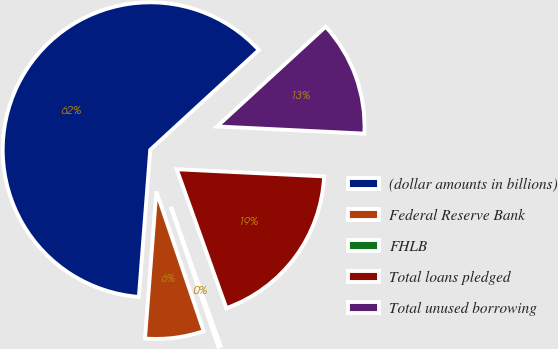Convert chart to OTSL. <chart><loc_0><loc_0><loc_500><loc_500><pie_chart><fcel>(dollar amounts in billions)<fcel>Federal Reserve Bank<fcel>FHLB<fcel>Total loans pledged<fcel>Total unused borrowing<nl><fcel>61.96%<fcel>6.43%<fcel>0.26%<fcel>18.77%<fcel>12.6%<nl></chart> 